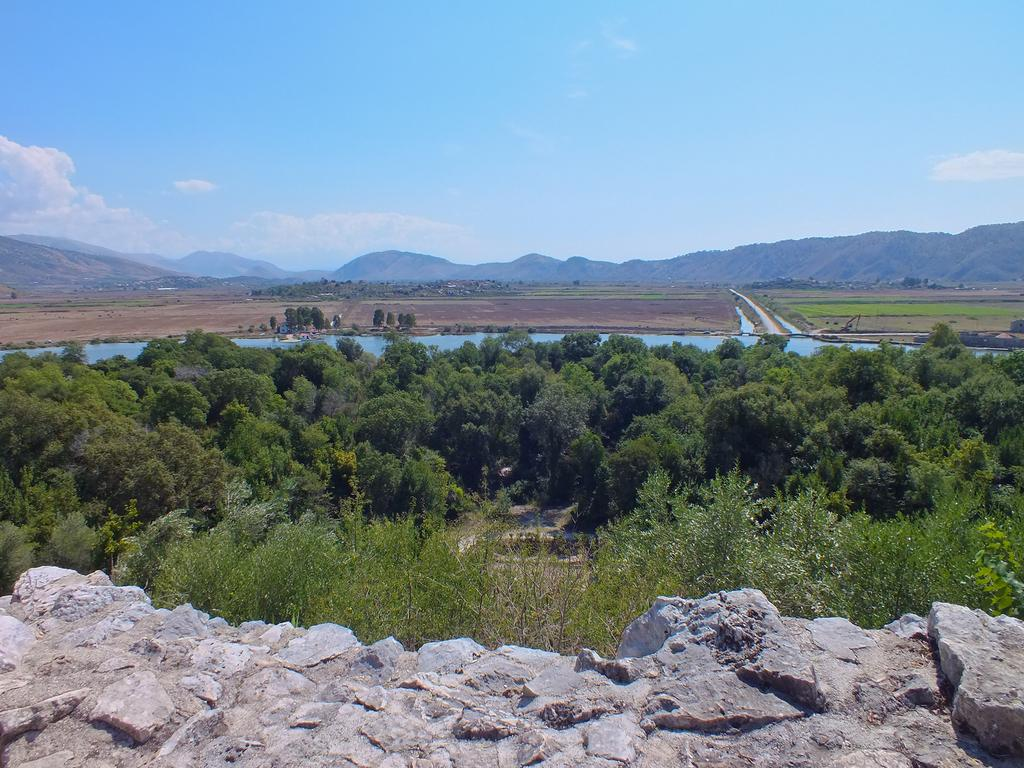What type of natural environment is depicted in the image? The image features trees, water, mountains, and a rock surface, indicating a natural environment. Can you describe the sky in the image? The sky is visible in the image, and there are clouds present. What type of water feature can be seen in the image? The water visible in the image is not specified, but it could be a river, lake, or other body of water. What is the terrain like in the image? The terrain in the image includes trees, mountains, and a rock surface. What type of linen is draped over the trees in the image? There is no linen draped over the trees in the image; the trees are not covered by any fabric or material. 